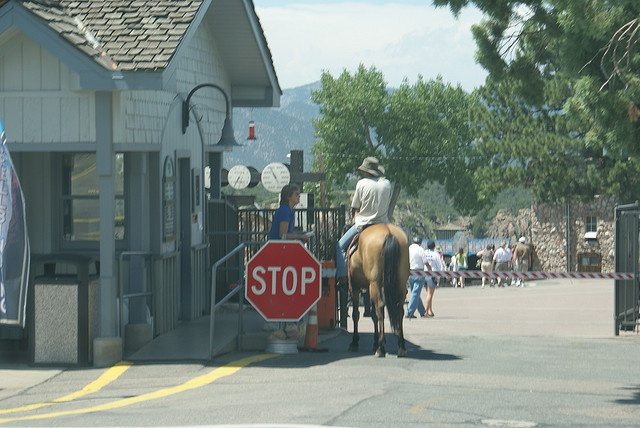Describe the objects in this image and their specific colors. I can see horse in darkblue, black, gray, and tan tones, stop sign in darkblue, brown, darkgray, and gray tones, people in darkblue, darkgray, gray, ivory, and blue tones, people in darkblue, gray, and black tones, and people in darkblue, white, gray, blue, and darkgray tones in this image. 